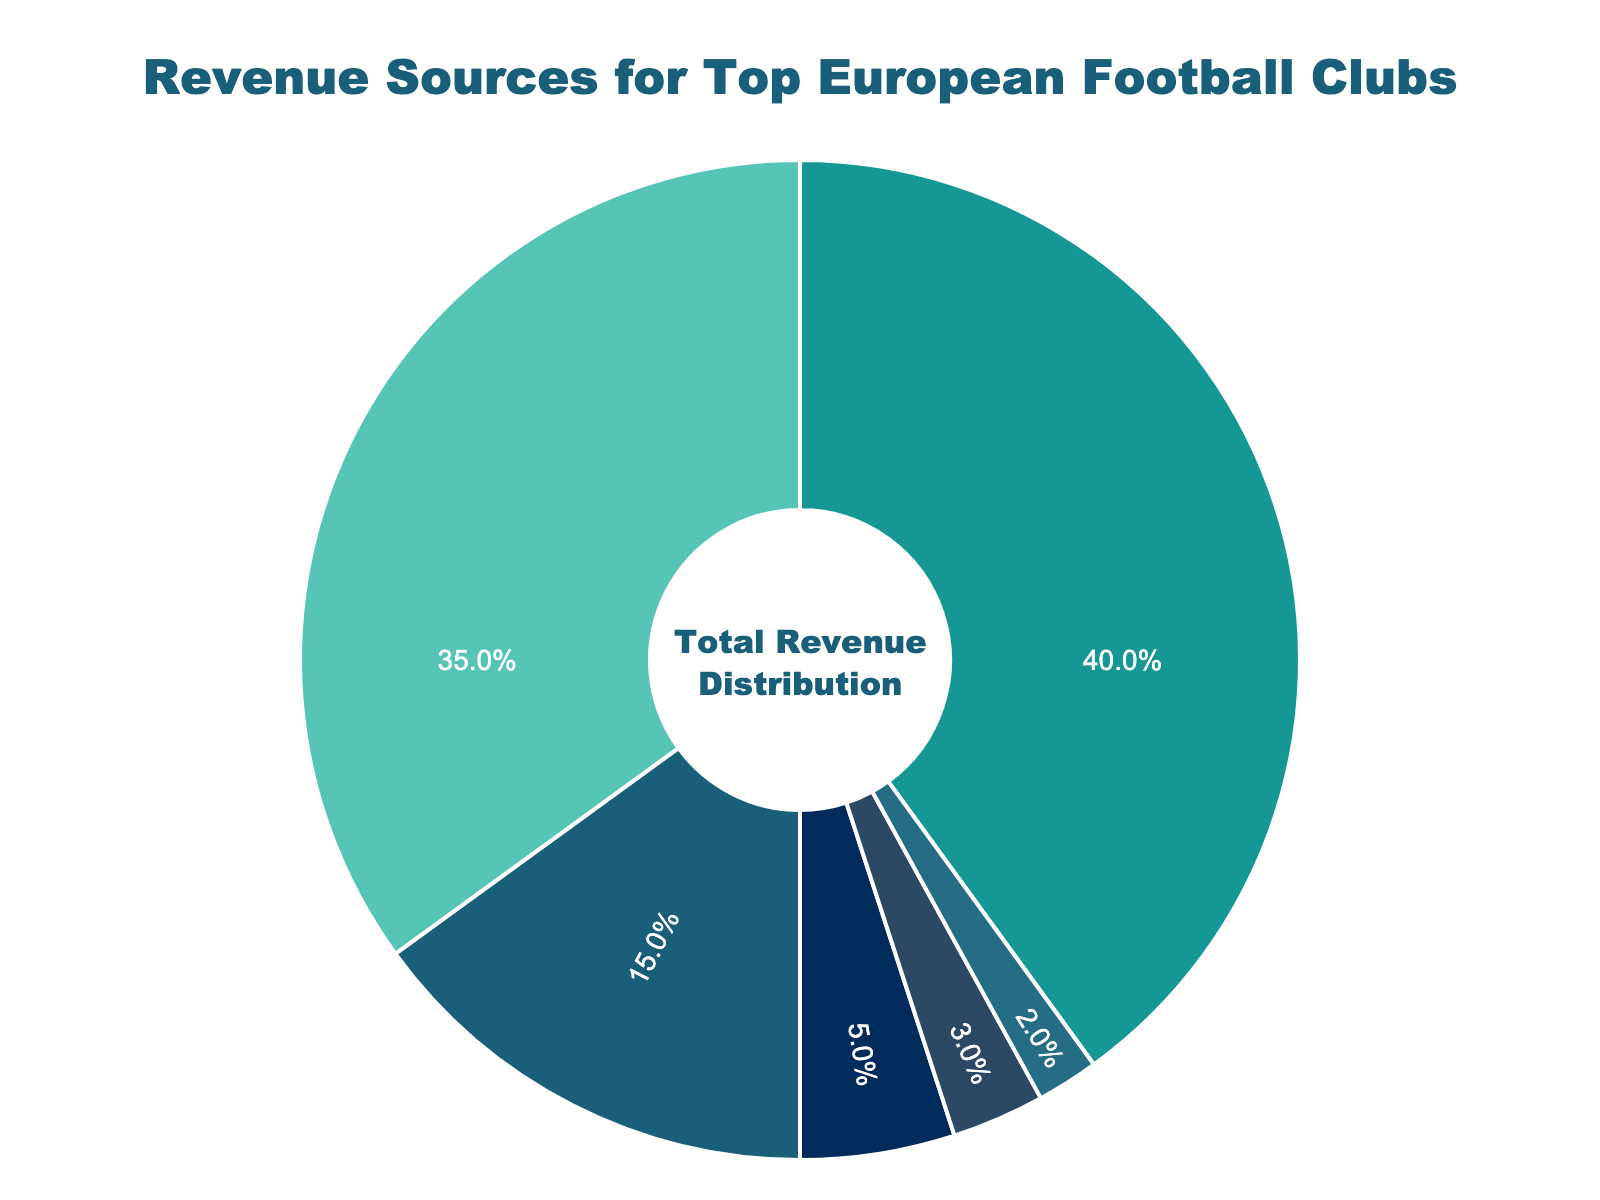What is the largest revenue source for top European football clubs? The pie chart shows various revenue sources with their respective percentages. The largest portion of the chart is Broadcasting Rights at 40%.
Answer: Broadcasting Rights What two revenue sources together account for more than half of the total revenue? By looking at the chart, we identify the percentages and add them. Broadcasting Rights (40%) + Commercial Deals (35%) = 75%, which is more than 50%.
Answer: Broadcasting Rights and Commercial Deals How much more does Broadcasting Rights contribute to revenue compared to Matchday Income? Broadcasting Rights contributes 40% while Matchday Income contributes 15%. The difference is 40% - 15% = 25%.
Answer: 25% Which revenue source is represented by the greenish-blue color? The greenish-blue section of the pie chart represents Commercial Deals.
Answer: Commercial Deals If another revenue source was added and it equally split the percentage from Commercial Deals, what would be the new percentage for each of the two sources? The current percentage of Commercial Deals is 35%. Splitting it equally gives 35% / 2 = 17.5% each.
Answer: 17.5% What is the combined percentage of the three smallest revenue sources? The three smallest revenue sources are Sponsorships (2%), Merchandise Sales (3%), and Player Transfer Fees (5%). Adding them gives 2% + 3% + 5% = 10%.
Answer: 10% What percentage would the Commercial Deals and Player Transfer Fees together contribute? Commercial Deals contribute 35% and Player Transfer Fees contribute 5%. Combined they contribute 35% + 5% = 40%.
Answer: 40% Which revenue source contributes the least to the total income? Sponsorships contribute only 2% to the total revenue, making it the least.
Answer: Sponsorships If the total revenue increases by 10% but the percentage distribution remains the same, what would be the new percentage for Matchday Income? Regardless of the increase in total revenue, the percentage distribution remains the same. Therefore, the new percentage for Matchday Income is still 15%.
Answer: 15% 